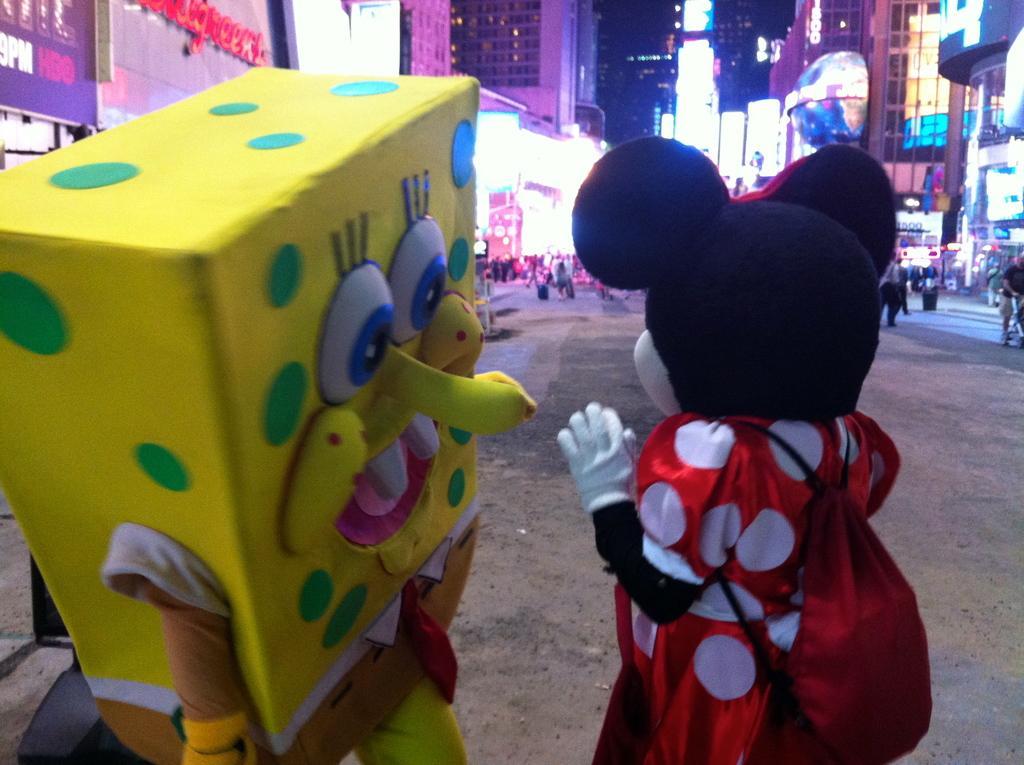Can you describe this image briefly? In this picture I can see buildings and I can see few people and couple of them wore masks and I can see lighting to the buildings and I can see a board with some text on the left side and I can see text on the buildings. 